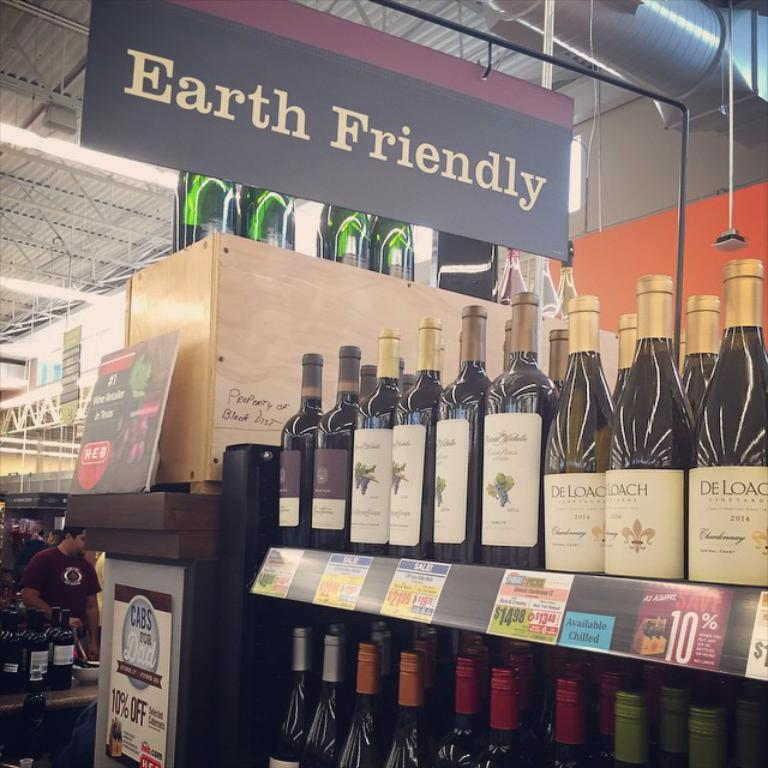<image>
Give a short and clear explanation of the subsequent image. the name De Loach is on a wine bottle 